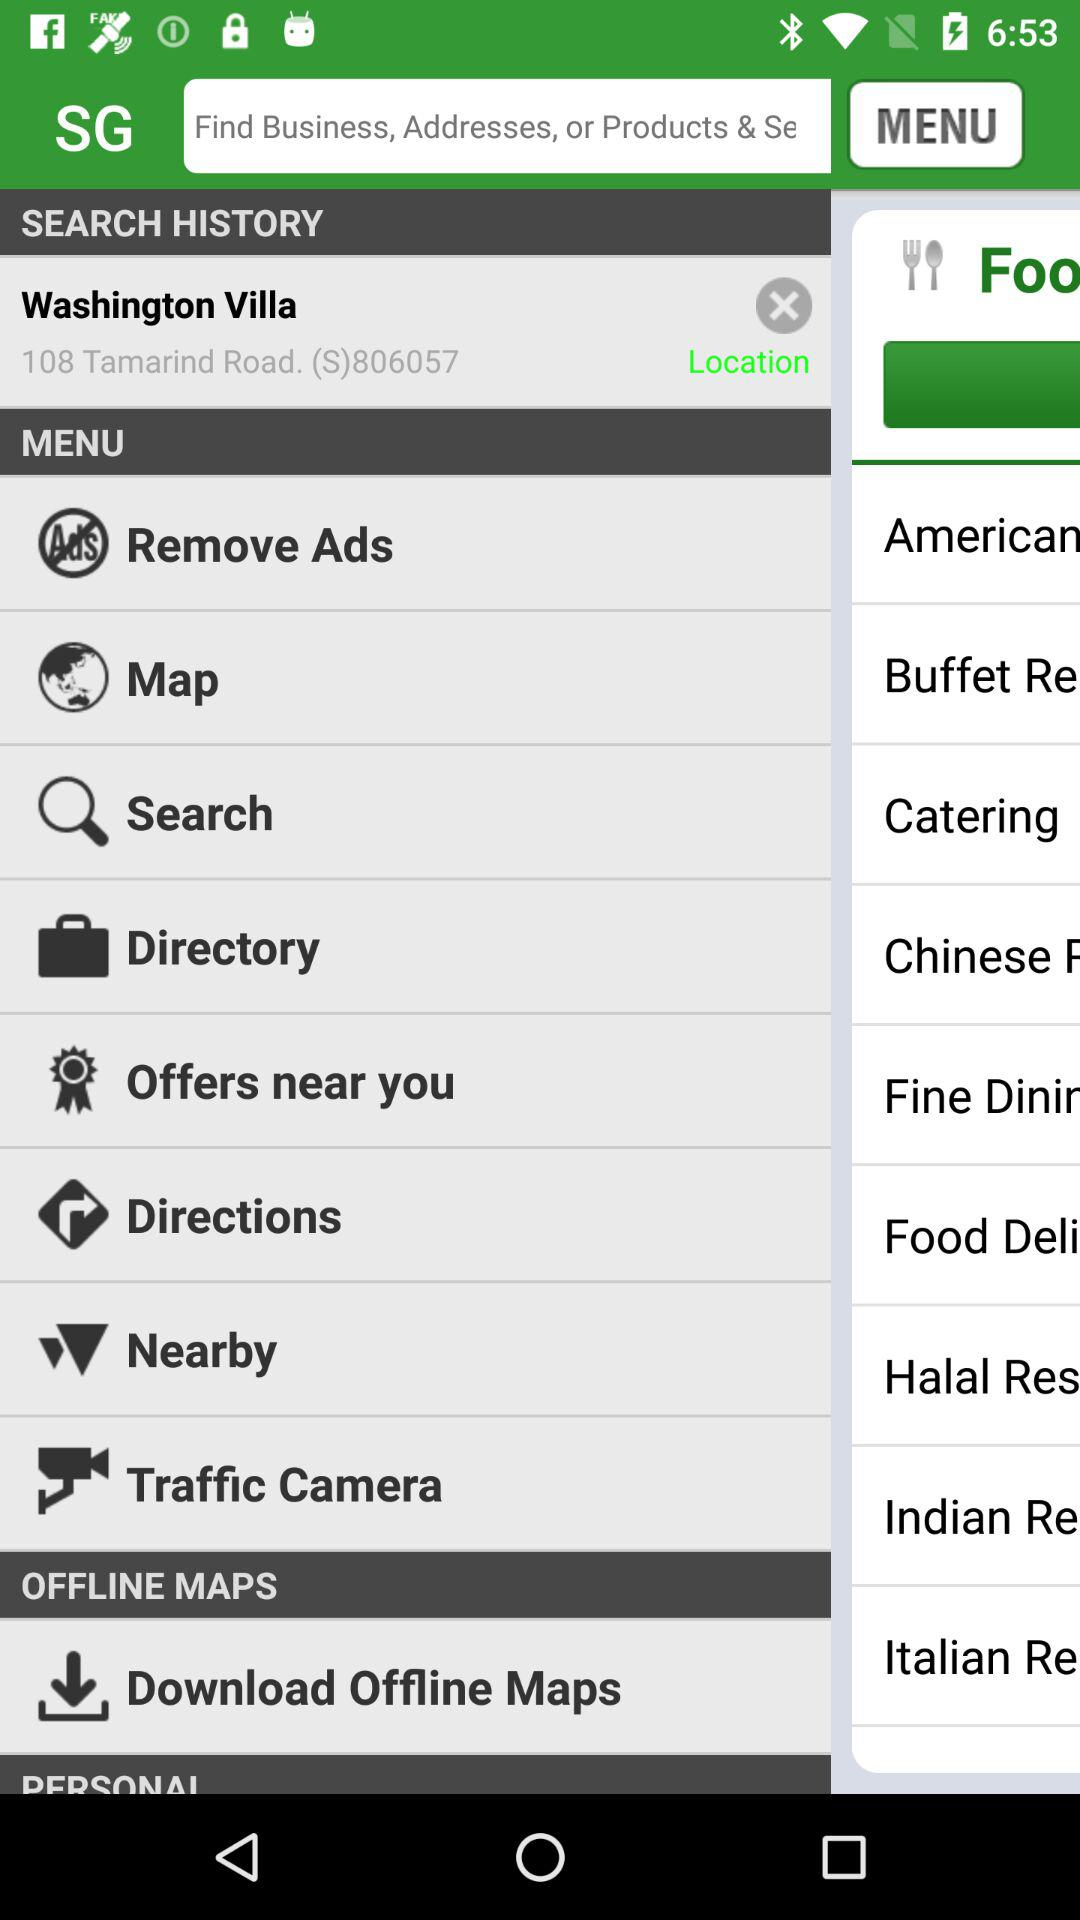What's the address of Washington Villa? The address is "108 Tamarind Road, (S)806057". 